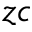Convert formula to latex. <formula><loc_0><loc_0><loc_500><loc_500>z c</formula> 